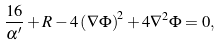Convert formula to latex. <formula><loc_0><loc_0><loc_500><loc_500>\frac { 1 6 } { \alpha ^ { \prime } } + R - 4 \left ( \nabla \Phi \right ) ^ { 2 } + 4 \nabla ^ { 2 } \Phi = 0 ,</formula> 